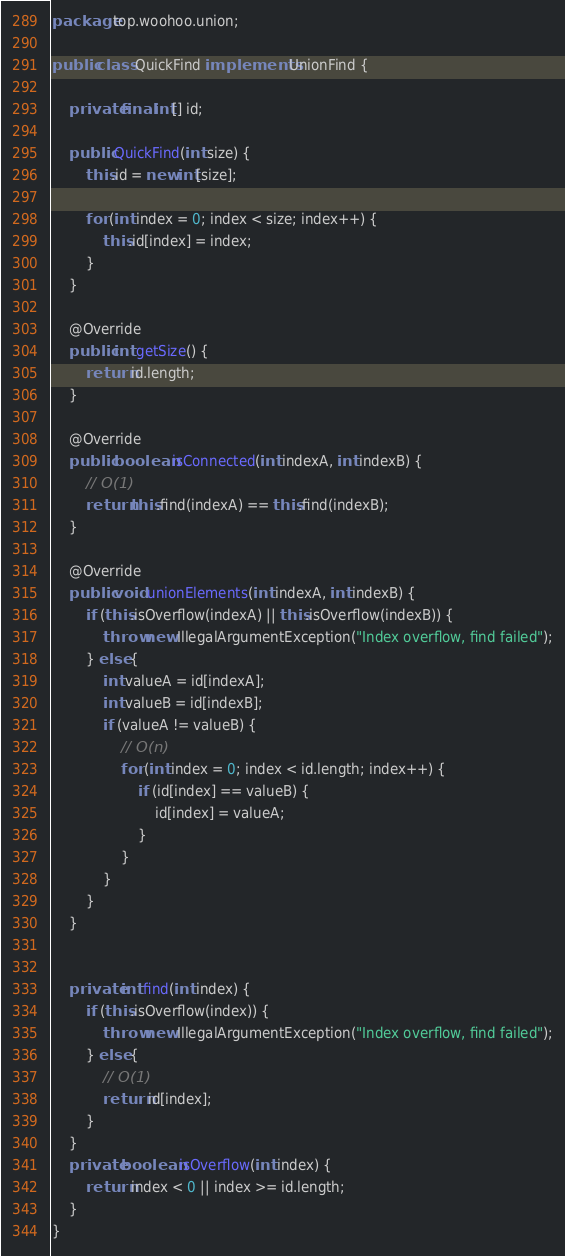Convert code to text. <code><loc_0><loc_0><loc_500><loc_500><_Java_>package top.woohoo.union;

public class QuickFind implements UnionFind {

    private final int[] id;

    public QuickFind(int size) {
        this.id = new int[size];

        for (int index = 0; index < size; index++) {
            this.id[index] = index;
        }
    }

    @Override
    public int getSize() {
        return id.length;
    }

    @Override
    public boolean isConnected(int indexA, int indexB) {
        // O(1)
        return this.find(indexA) == this.find(indexB);
    }

    @Override
    public void unionElements(int indexA, int indexB) {
        if (this.isOverflow(indexA) || this.isOverflow(indexB)) {
            throw new IllegalArgumentException("Index overflow, find failed");
        } else {
            int valueA = id[indexA];
            int valueB = id[indexB];
            if (valueA != valueB) {
                // O(n)
                for (int index = 0; index < id.length; index++) {
                    if (id[index] == valueB) {
                        id[index] = valueA;
                    }
                }
            }
        }
    }


    private int find(int index) {
        if (this.isOverflow(index)) {
            throw new IllegalArgumentException("Index overflow, find failed");
        } else {
            // O(1)
            return id[index];
        }
    }
    private boolean isOverflow(int index) {
        return index < 0 || index >= id.length;
    }
}
</code> 